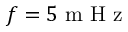Convert formula to latex. <formula><loc_0><loc_0><loc_500><loc_500>f = 5 m H z</formula> 